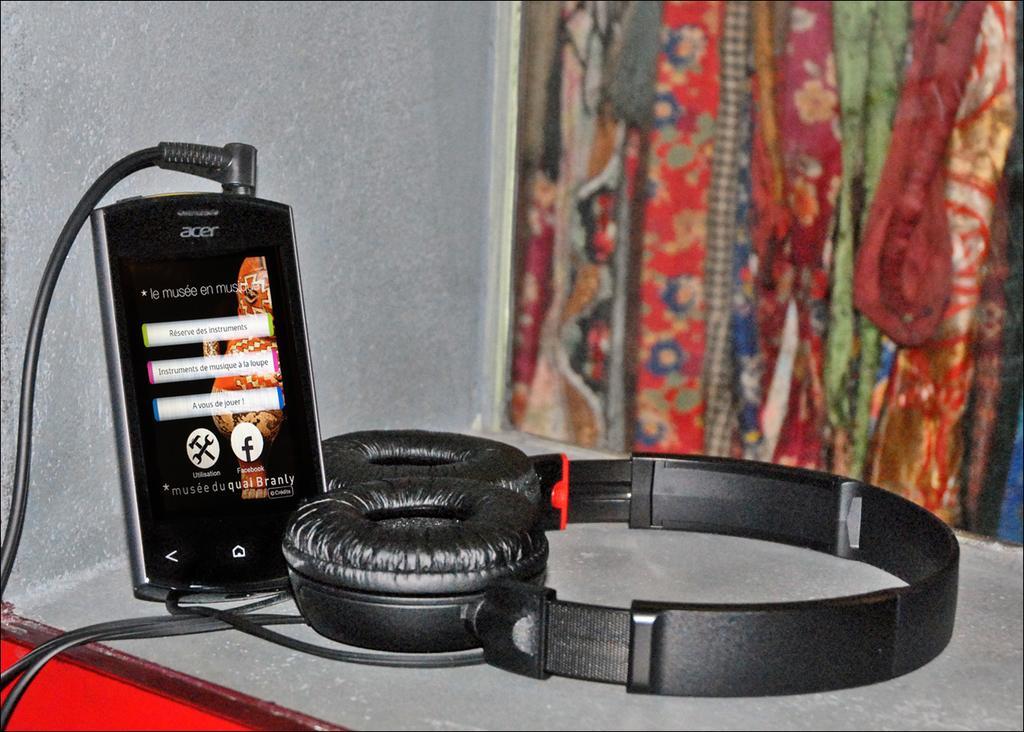Please provide a concise description of this image. This image consists of a mobile along with a headset kept on the desk. On the right, it looks like a window. In the background, there is a wall. 